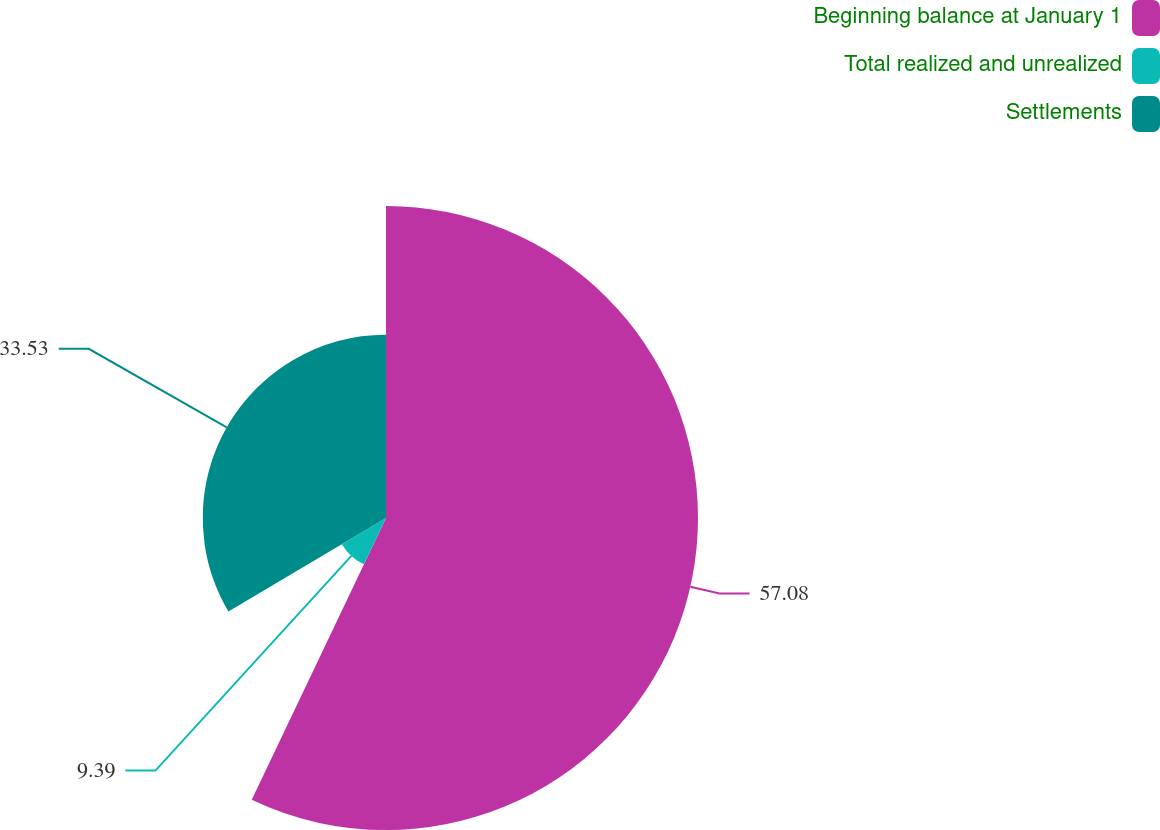<chart> <loc_0><loc_0><loc_500><loc_500><pie_chart><fcel>Beginning balance at January 1<fcel>Total realized and unrealized<fcel>Settlements<nl><fcel>57.08%<fcel>9.39%<fcel>33.53%<nl></chart> 